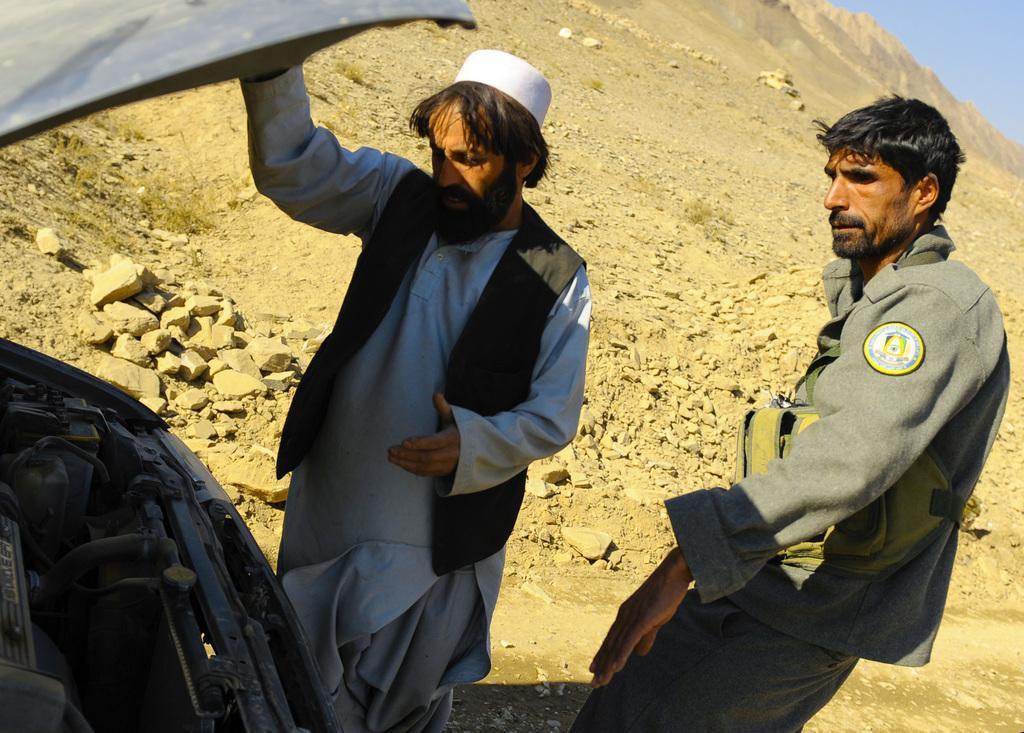Can you describe this image briefly? This image consists of two men. On the right, the man is wearing a coat. In the front, we can see the man is wearing a black vest and a white cap. On the left, there is car. And the bonnet is opened. In the background, we can see the rocks and soil. At the top, there is sky. 